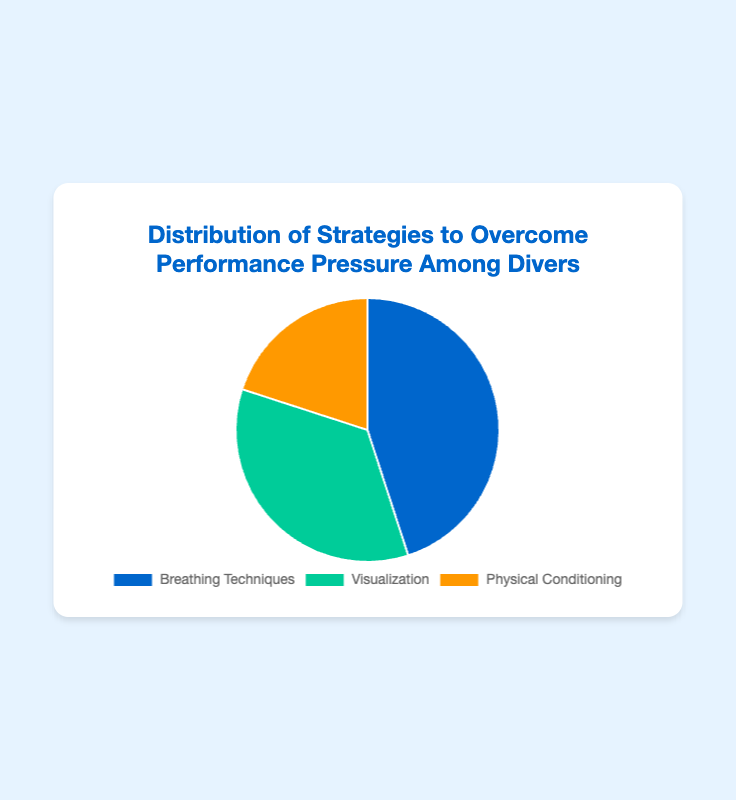What strategy is the most commonly used to overcome performance pressure according to the pie chart? The pie chart shows the distribution of strategies among divers. The strategy with the largest percentage is "Breathing Techniques," which holds 45%.
Answer: Breathing Techniques What is the combined percentage of divers who use Visualization and Physical Conditioning techniques? To find the combined percentage, add the percentage of divers using Visualization (35%) and those using Physical Conditioning (20%): 35% + 20% = 55%.
Answer: 55% Which strategy is less commonly used than Visualization but more commonly used than Physical Conditioning? The pie chart shows three strategies: Breathing Techniques (45%), Visualization (35%), and Physical Conditioning (20%). Visualization is more common than Physical Conditioning, but Breathing Techniques is more common than both. Therefore, the strategy that is less common than Visualization but more common than Physical Conditioning is "Breathing Techniques."
Answer: Breathing Techniques How many times greater is the percentage of Breathing Techniques compared to Physical Conditioning? The percentage for Breathing Techniques is 45%, and for Physical Conditioning, it is 20%. To find how many times greater: 45 / 20 = 2.25.
Answer: 2.25 times What percentage of divers do not use Breathing Techniques? If 45% of divers use Breathing Techniques, the percentage that does not use it is: 100% - 45% = 55%.
Answer: 55% Describe the color associated with the strategy that holds the smallest percentage in the pie chart. The smallest percentage is held by Physical Conditioning at 20%. According to the chart colors, Physical Conditioning is represented by the color orange.
Answer: Orange What is the ratio of divers who use Visualization to those who use Physical Conditioning? The percentage for Visualization is 35%, and for Physical Conditioning, it is 20%. The ratio is 35:20, which can be simplified to 7:4.
Answer: 7:4 If we were to visually combine the segments representing Breathing Techniques and Physical Conditioning, what fraction of the pie chart would they cover together? The percentage for Breathing Techniques is 45%, and for Physical Conditioning, it is 20%. Combined, they cover 45% + 20% = 65% of the pie chart. Since a pie chart represents 100% in total, the combined fraction is 65/100.
Answer: 65% 